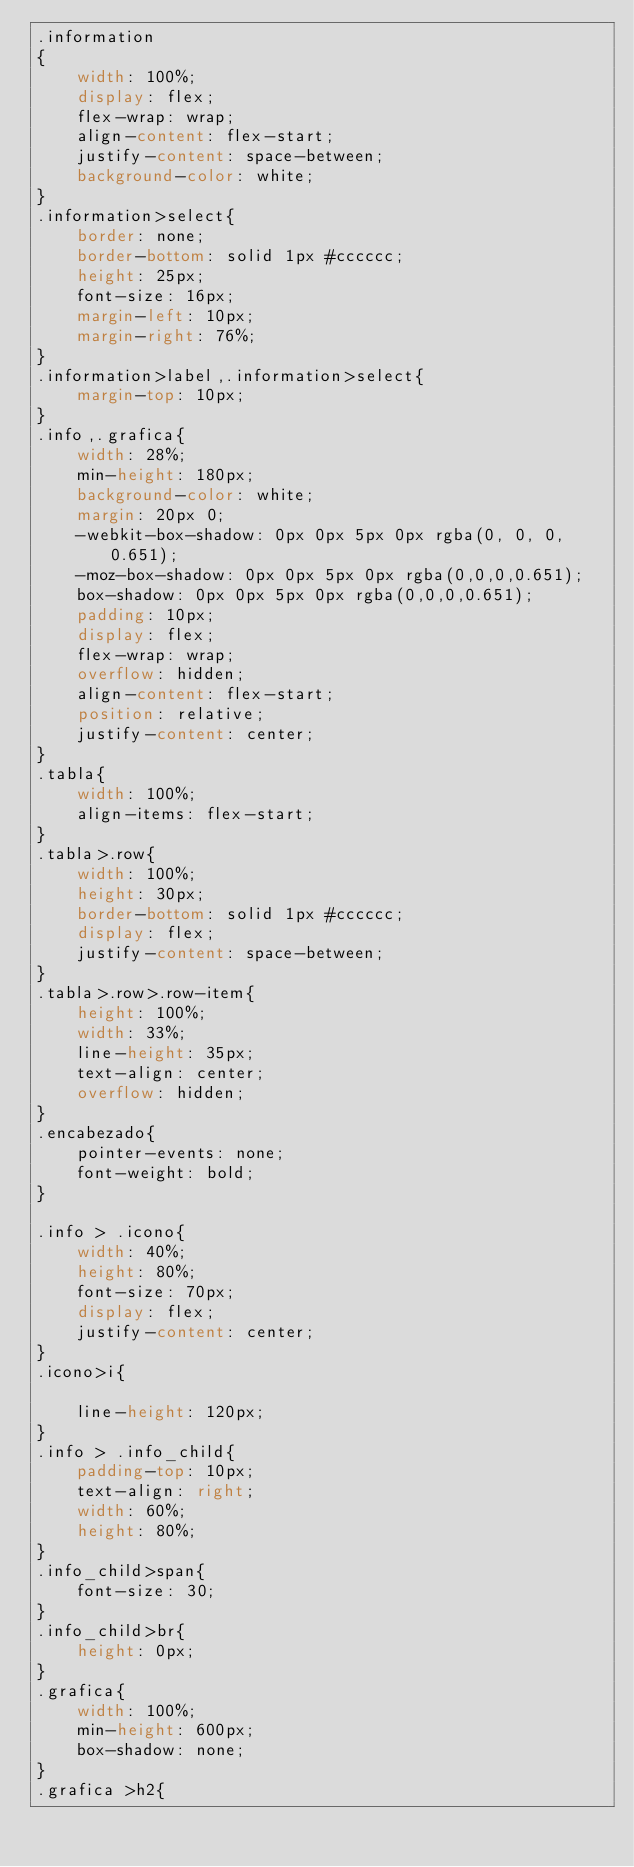<code> <loc_0><loc_0><loc_500><loc_500><_CSS_>.information
{
    width: 100%;
    display: flex;
    flex-wrap: wrap;
    align-content: flex-start;
    justify-content: space-between;
    background-color: white;
}
.information>select{
    border: none;
    border-bottom: solid 1px #cccccc;
    height: 25px;
    font-size: 16px;
    margin-left: 10px;
    margin-right: 76%;
}
.information>label,.information>select{
    margin-top: 10px;
}
.info,.grafica{
    width: 28%;
    min-height: 180px;
    background-color: white;
    margin: 20px 0;
    -webkit-box-shadow: 0px 0px 5px 0px rgba(0, 0, 0, 0.651);
    -moz-box-shadow: 0px 0px 5px 0px rgba(0,0,0,0.651);
    box-shadow: 0px 0px 5px 0px rgba(0,0,0,0.651);
    padding: 10px;
    display: flex;
    flex-wrap: wrap;
    overflow: hidden;
    align-content: flex-start;
    position: relative;
    justify-content: center;
}
.tabla{
    width: 100%;
    align-items: flex-start;
}
.tabla>.row{
    width: 100%;
    height: 30px;
    border-bottom: solid 1px #cccccc;
    display: flex;
    justify-content: space-between;
}
.tabla>.row>.row-item{
    height: 100%;
    width: 33%;
    line-height: 35px;
    text-align: center;
    overflow: hidden;
}
.encabezado{
    pointer-events: none;
    font-weight: bold;
}

.info > .icono{
    width: 40%;
    height: 80%;
    font-size: 70px;
    display: flex;
    justify-content: center;
}
.icono>i{
    
    line-height: 120px;
}
.info > .info_child{
    padding-top: 10px;
    text-align: right;
    width: 60%;
    height: 80%;
}
.info_child>span{
    font-size: 30;
}
.info_child>br{
    height: 0px;
}
.grafica{
    width: 100%;
    min-height: 600px;
    box-shadow: none;
}
.grafica >h2{</code> 